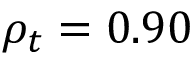Convert formula to latex. <formula><loc_0><loc_0><loc_500><loc_500>\rho _ { t } = 0 . 9 0</formula> 